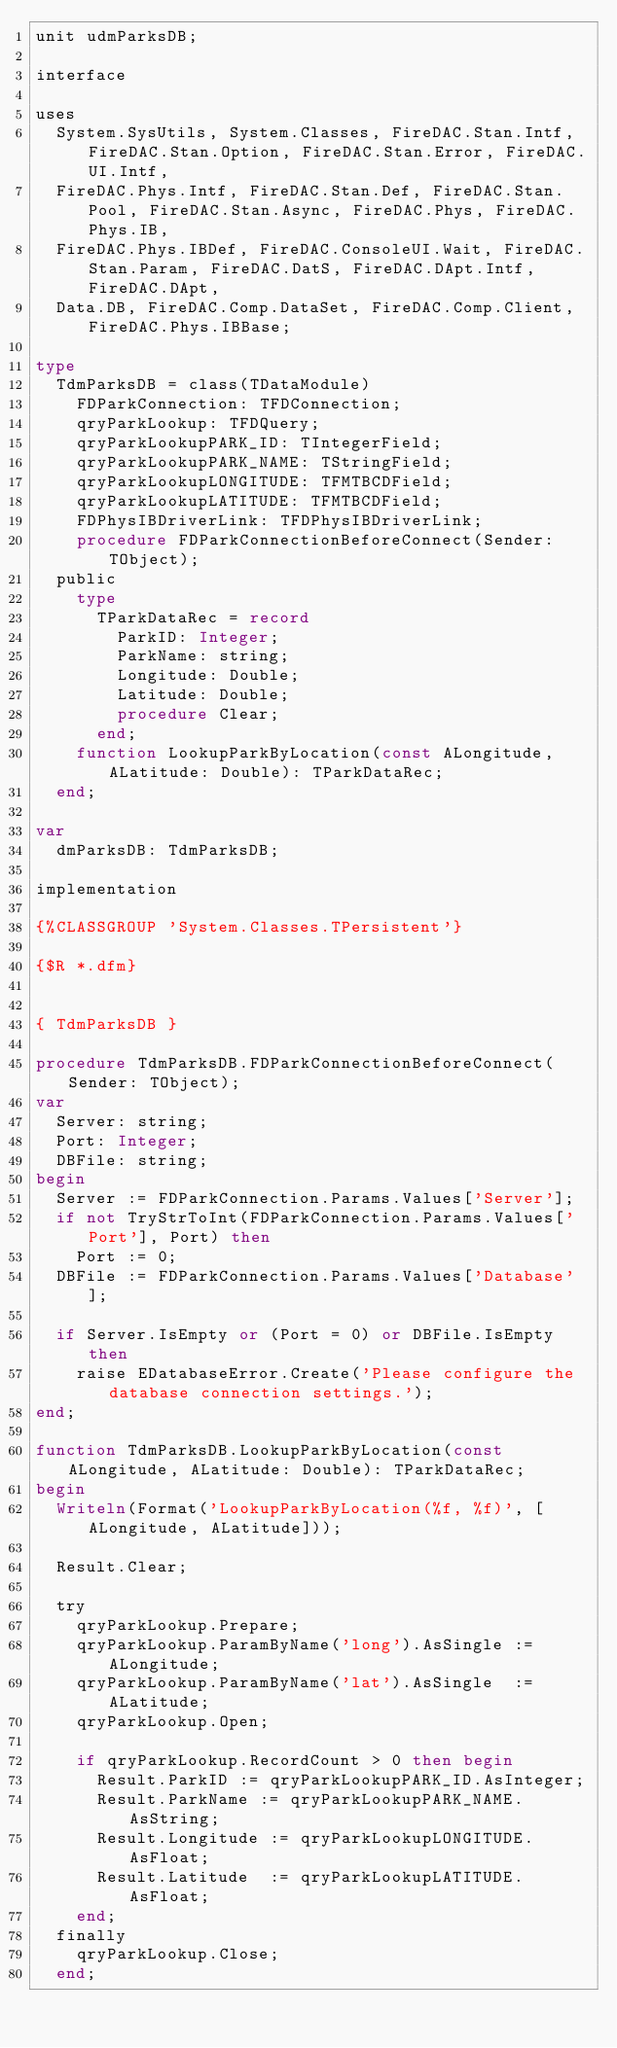<code> <loc_0><loc_0><loc_500><loc_500><_Pascal_>unit udmParksDB;

interface

uses
  System.SysUtils, System.Classes, FireDAC.Stan.Intf, FireDAC.Stan.Option, FireDAC.Stan.Error, FireDAC.UI.Intf,
  FireDAC.Phys.Intf, FireDAC.Stan.Def, FireDAC.Stan.Pool, FireDAC.Stan.Async, FireDAC.Phys, FireDAC.Phys.IB,
  FireDAC.Phys.IBDef, FireDAC.ConsoleUI.Wait, FireDAC.Stan.Param, FireDAC.DatS, FireDAC.DApt.Intf, FireDAC.DApt,
  Data.DB, FireDAC.Comp.DataSet, FireDAC.Comp.Client, FireDAC.Phys.IBBase;

type
  TdmParksDB = class(TDataModule)
    FDParkConnection: TFDConnection;
    qryParkLookup: TFDQuery;
    qryParkLookupPARK_ID: TIntegerField;
    qryParkLookupPARK_NAME: TStringField;
    qryParkLookupLONGITUDE: TFMTBCDField;
    qryParkLookupLATITUDE: TFMTBCDField;
    FDPhysIBDriverLink: TFDPhysIBDriverLink;
    procedure FDParkConnectionBeforeConnect(Sender: TObject);
  public
    type
      TParkDataRec = record
        ParkID: Integer;
        ParkName: string;
        Longitude: Double;
        Latitude: Double;
        procedure Clear;
      end;
    function LookupParkByLocation(const ALongitude, ALatitude: Double): TParkDataRec;
  end;

var
  dmParksDB: TdmParksDB;

implementation

{%CLASSGROUP 'System.Classes.TPersistent'}

{$R *.dfm}


{ TdmParksDB }

procedure TdmParksDB.FDParkConnectionBeforeConnect(Sender: TObject);
var
  Server: string;
  Port: Integer;
  DBFile: string;
begin
  Server := FDParkConnection.Params.Values['Server'];
  if not TryStrToInt(FDParkConnection.Params.Values['Port'], Port) then
    Port := 0;
  DBFile := FDParkConnection.Params.Values['Database'];

  if Server.IsEmpty or (Port = 0) or DBFile.IsEmpty then
    raise EDatabaseError.Create('Please configure the database connection settings.');
end;

function TdmParksDB.LookupParkByLocation(const ALongitude, ALatitude: Double): TParkDataRec;
begin
  Writeln(Format('LookupParkByLocation(%f, %f)', [ALongitude, ALatitude]));

  Result.Clear;

  try
    qryParkLookup.Prepare;
    qryParkLookup.ParamByName('long').AsSingle := ALongitude;
    qryParkLookup.ParamByName('lat').AsSingle  := ALatitude;
    qryParkLookup.Open;

    if qryParkLookup.RecordCount > 0 then begin
      Result.ParkID := qryParkLookupPARK_ID.AsInteger;
      Result.ParkName := qryParkLookupPARK_NAME.AsString;
      Result.Longitude := qryParkLookupLONGITUDE.AsFloat;
      Result.Latitude  := qryParkLookupLATITUDE.AsFloat;
    end;
  finally
    qryParkLookup.Close;
  end;
</code> 